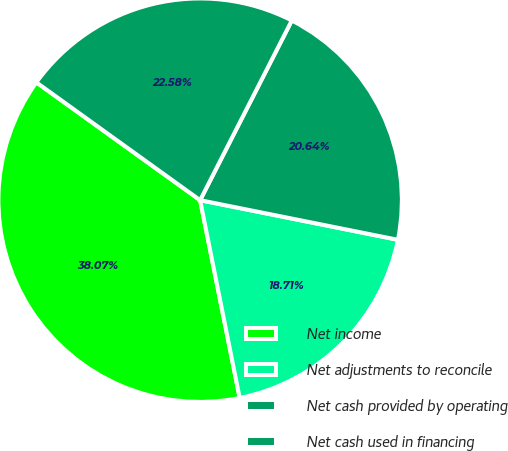Convert chart to OTSL. <chart><loc_0><loc_0><loc_500><loc_500><pie_chart><fcel>Net income<fcel>Net adjustments to reconcile<fcel>Net cash provided by operating<fcel>Net cash used in financing<nl><fcel>38.07%<fcel>18.71%<fcel>20.64%<fcel>22.58%<nl></chart> 